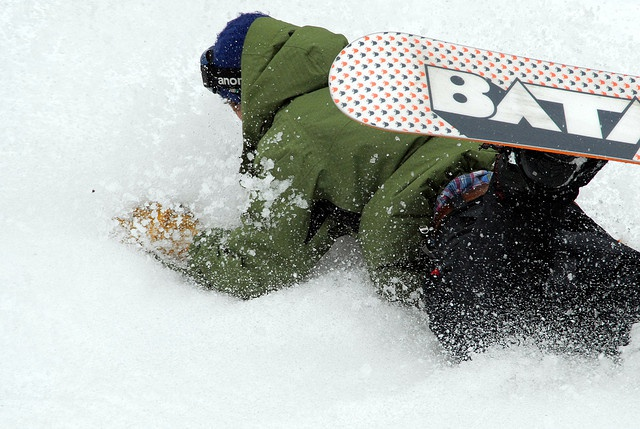Describe the objects in this image and their specific colors. I can see people in white, black, gray, darkgreen, and darkgray tones and snowboard in white, gray, darkgray, and lightpink tones in this image. 